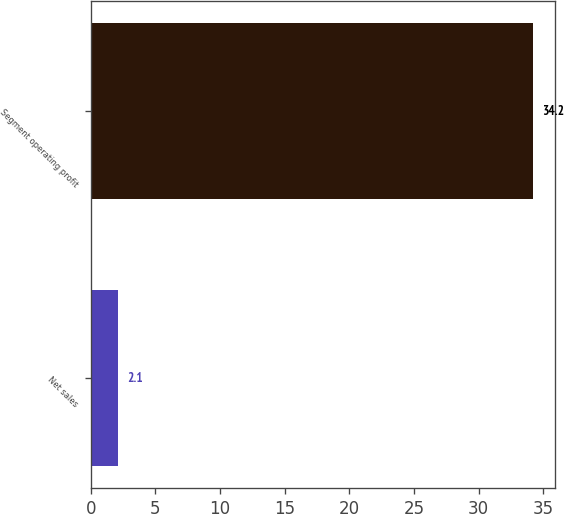Convert chart to OTSL. <chart><loc_0><loc_0><loc_500><loc_500><bar_chart><fcel>Net sales<fcel>Segment operating profit<nl><fcel>2.1<fcel>34.2<nl></chart> 